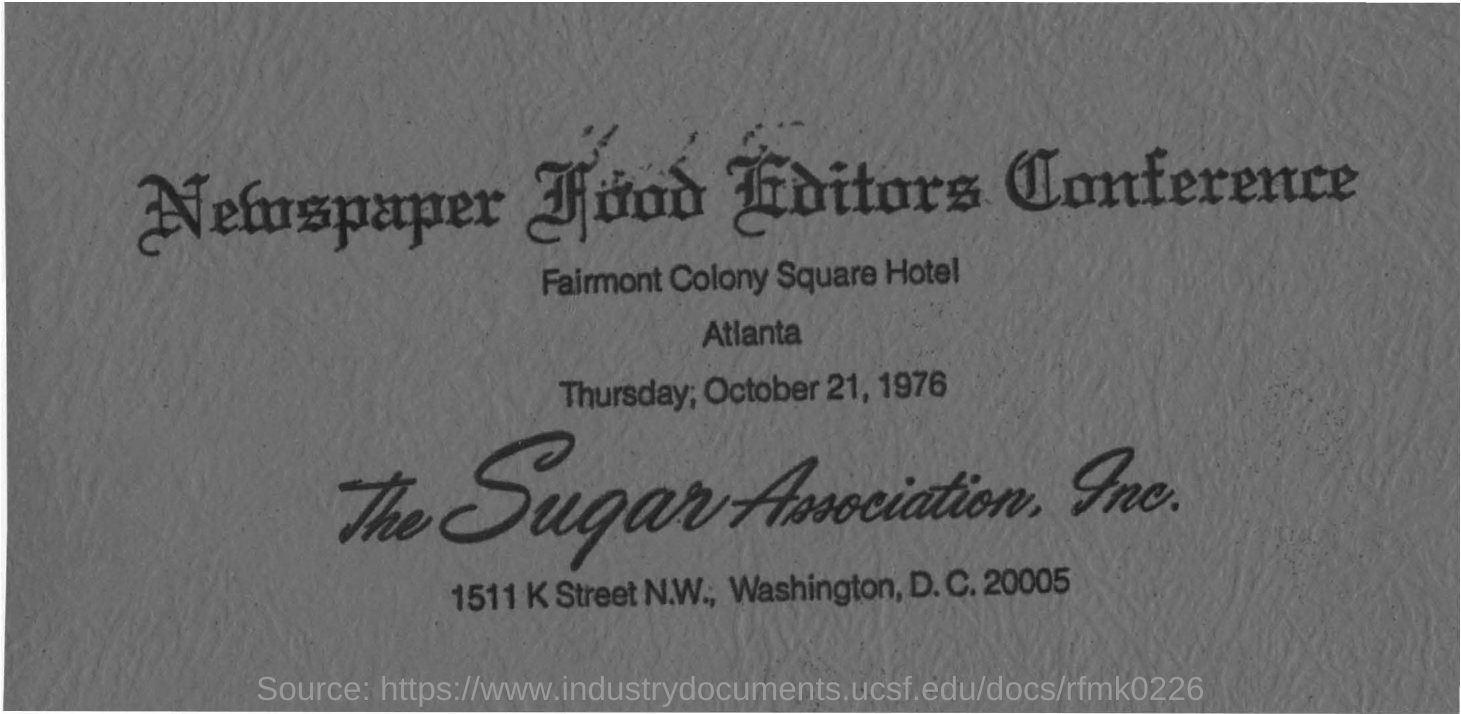Identify some key points in this picture. The "Newspaper Food Editors Conference" is the name of the conference. On which date was the conference held? The conference was held on Thursday, October 21, 1976. The Fairmont Colony Square Hotel is the location where the conference is being held. 